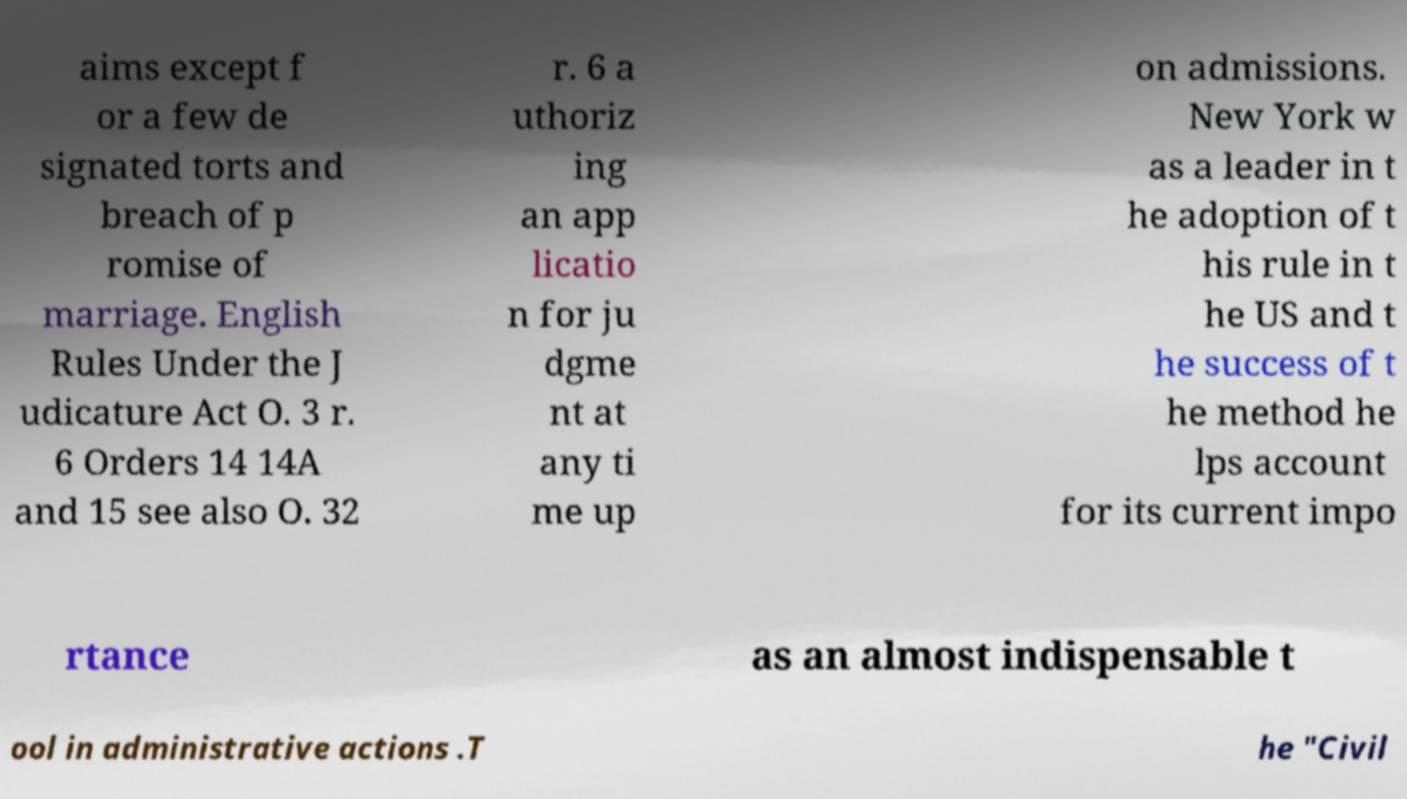There's text embedded in this image that I need extracted. Can you transcribe it verbatim? aims except f or a few de signated torts and breach of p romise of marriage. English Rules Under the J udicature Act O. 3 r. 6 Orders 14 14A and 15 see also O. 32 r. 6 a uthoriz ing an app licatio n for ju dgme nt at any ti me up on admissions. New York w as a leader in t he adoption of t his rule in t he US and t he success of t he method he lps account for its current impo rtance as an almost indispensable t ool in administrative actions .T he "Civil 